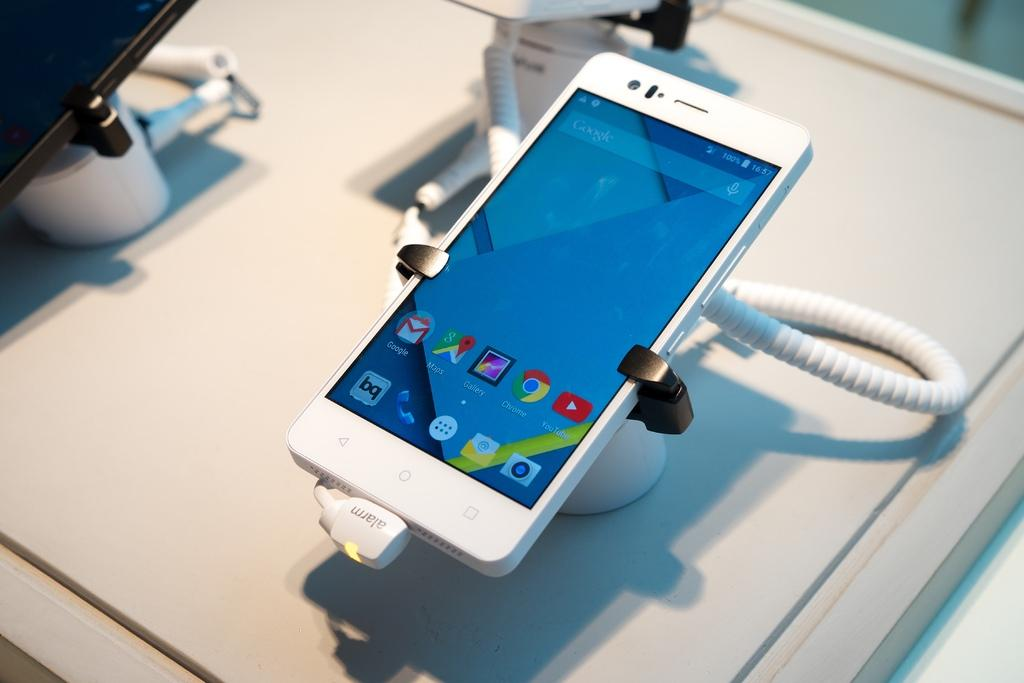Provide a one-sentence caption for the provided image. A phone secured to a table with 100% battery. 